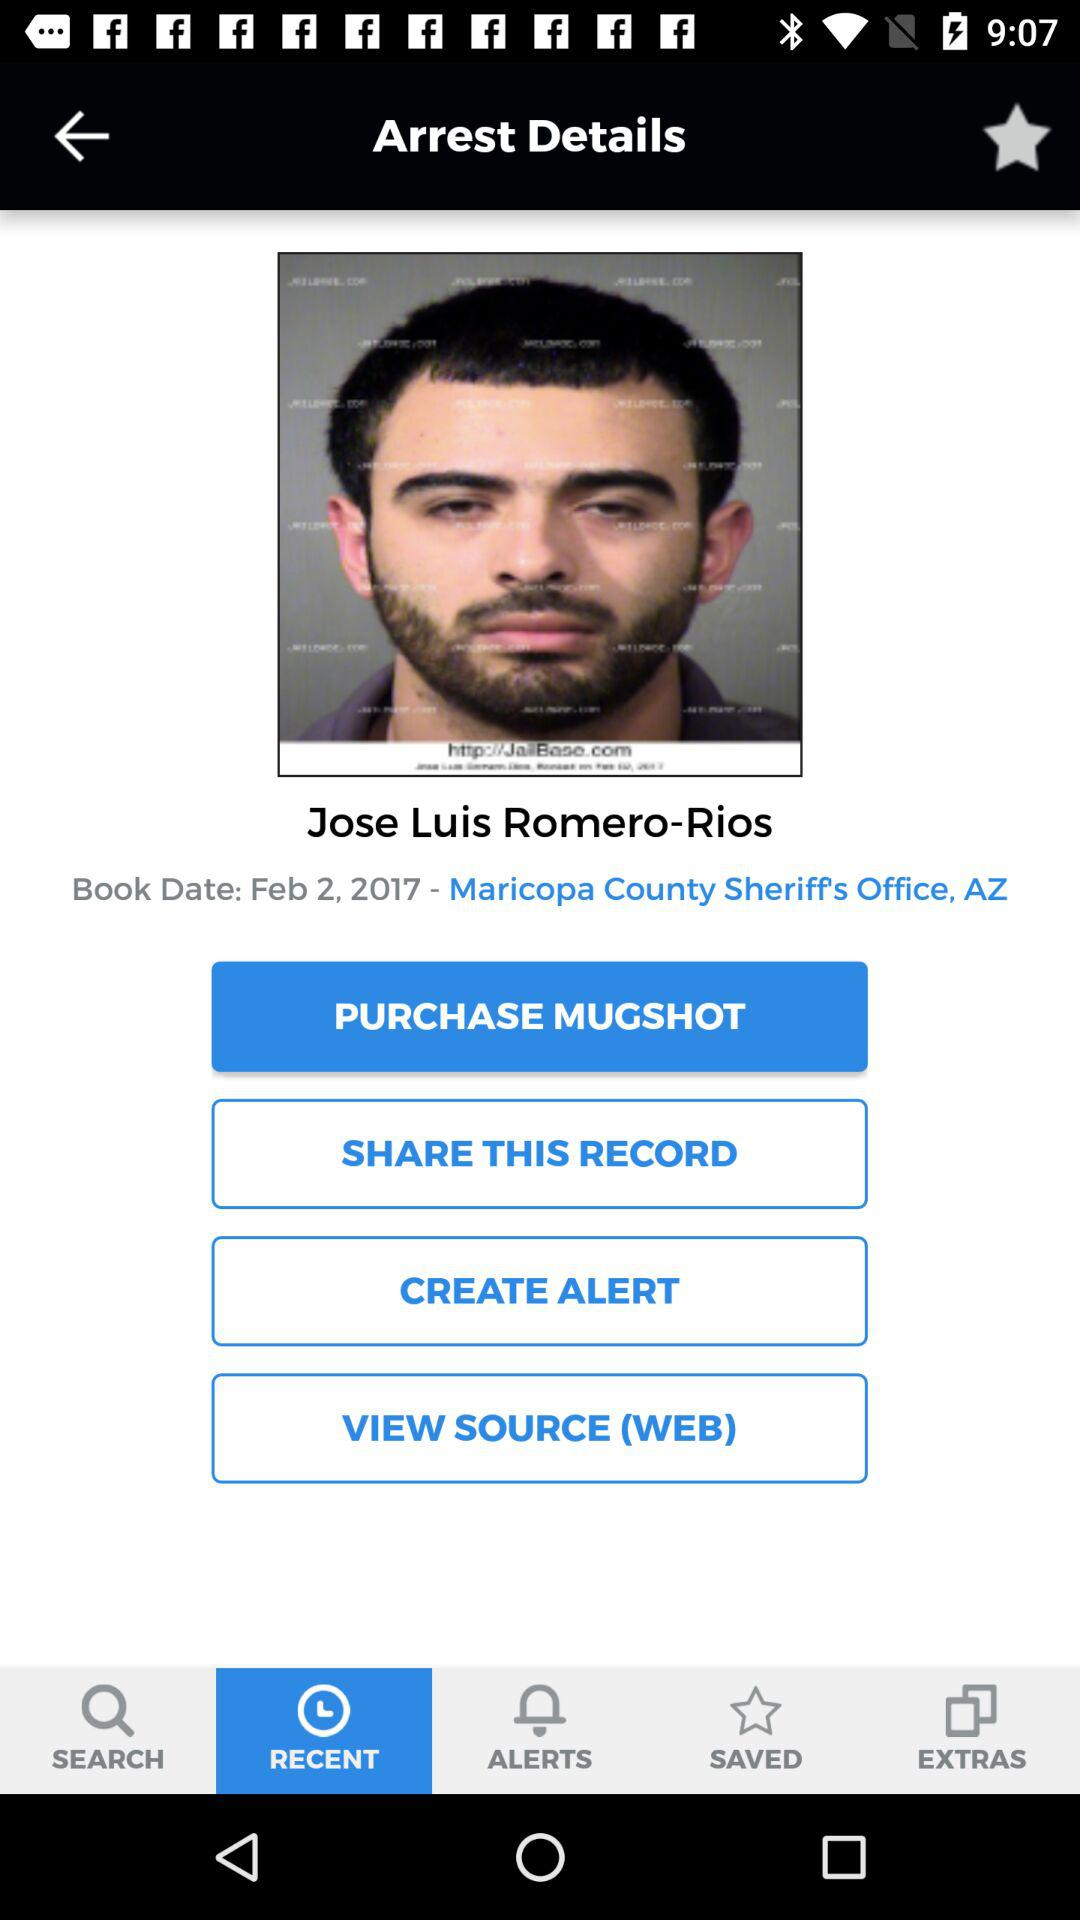What is the booking date? The booking date is February 2, 2017. 